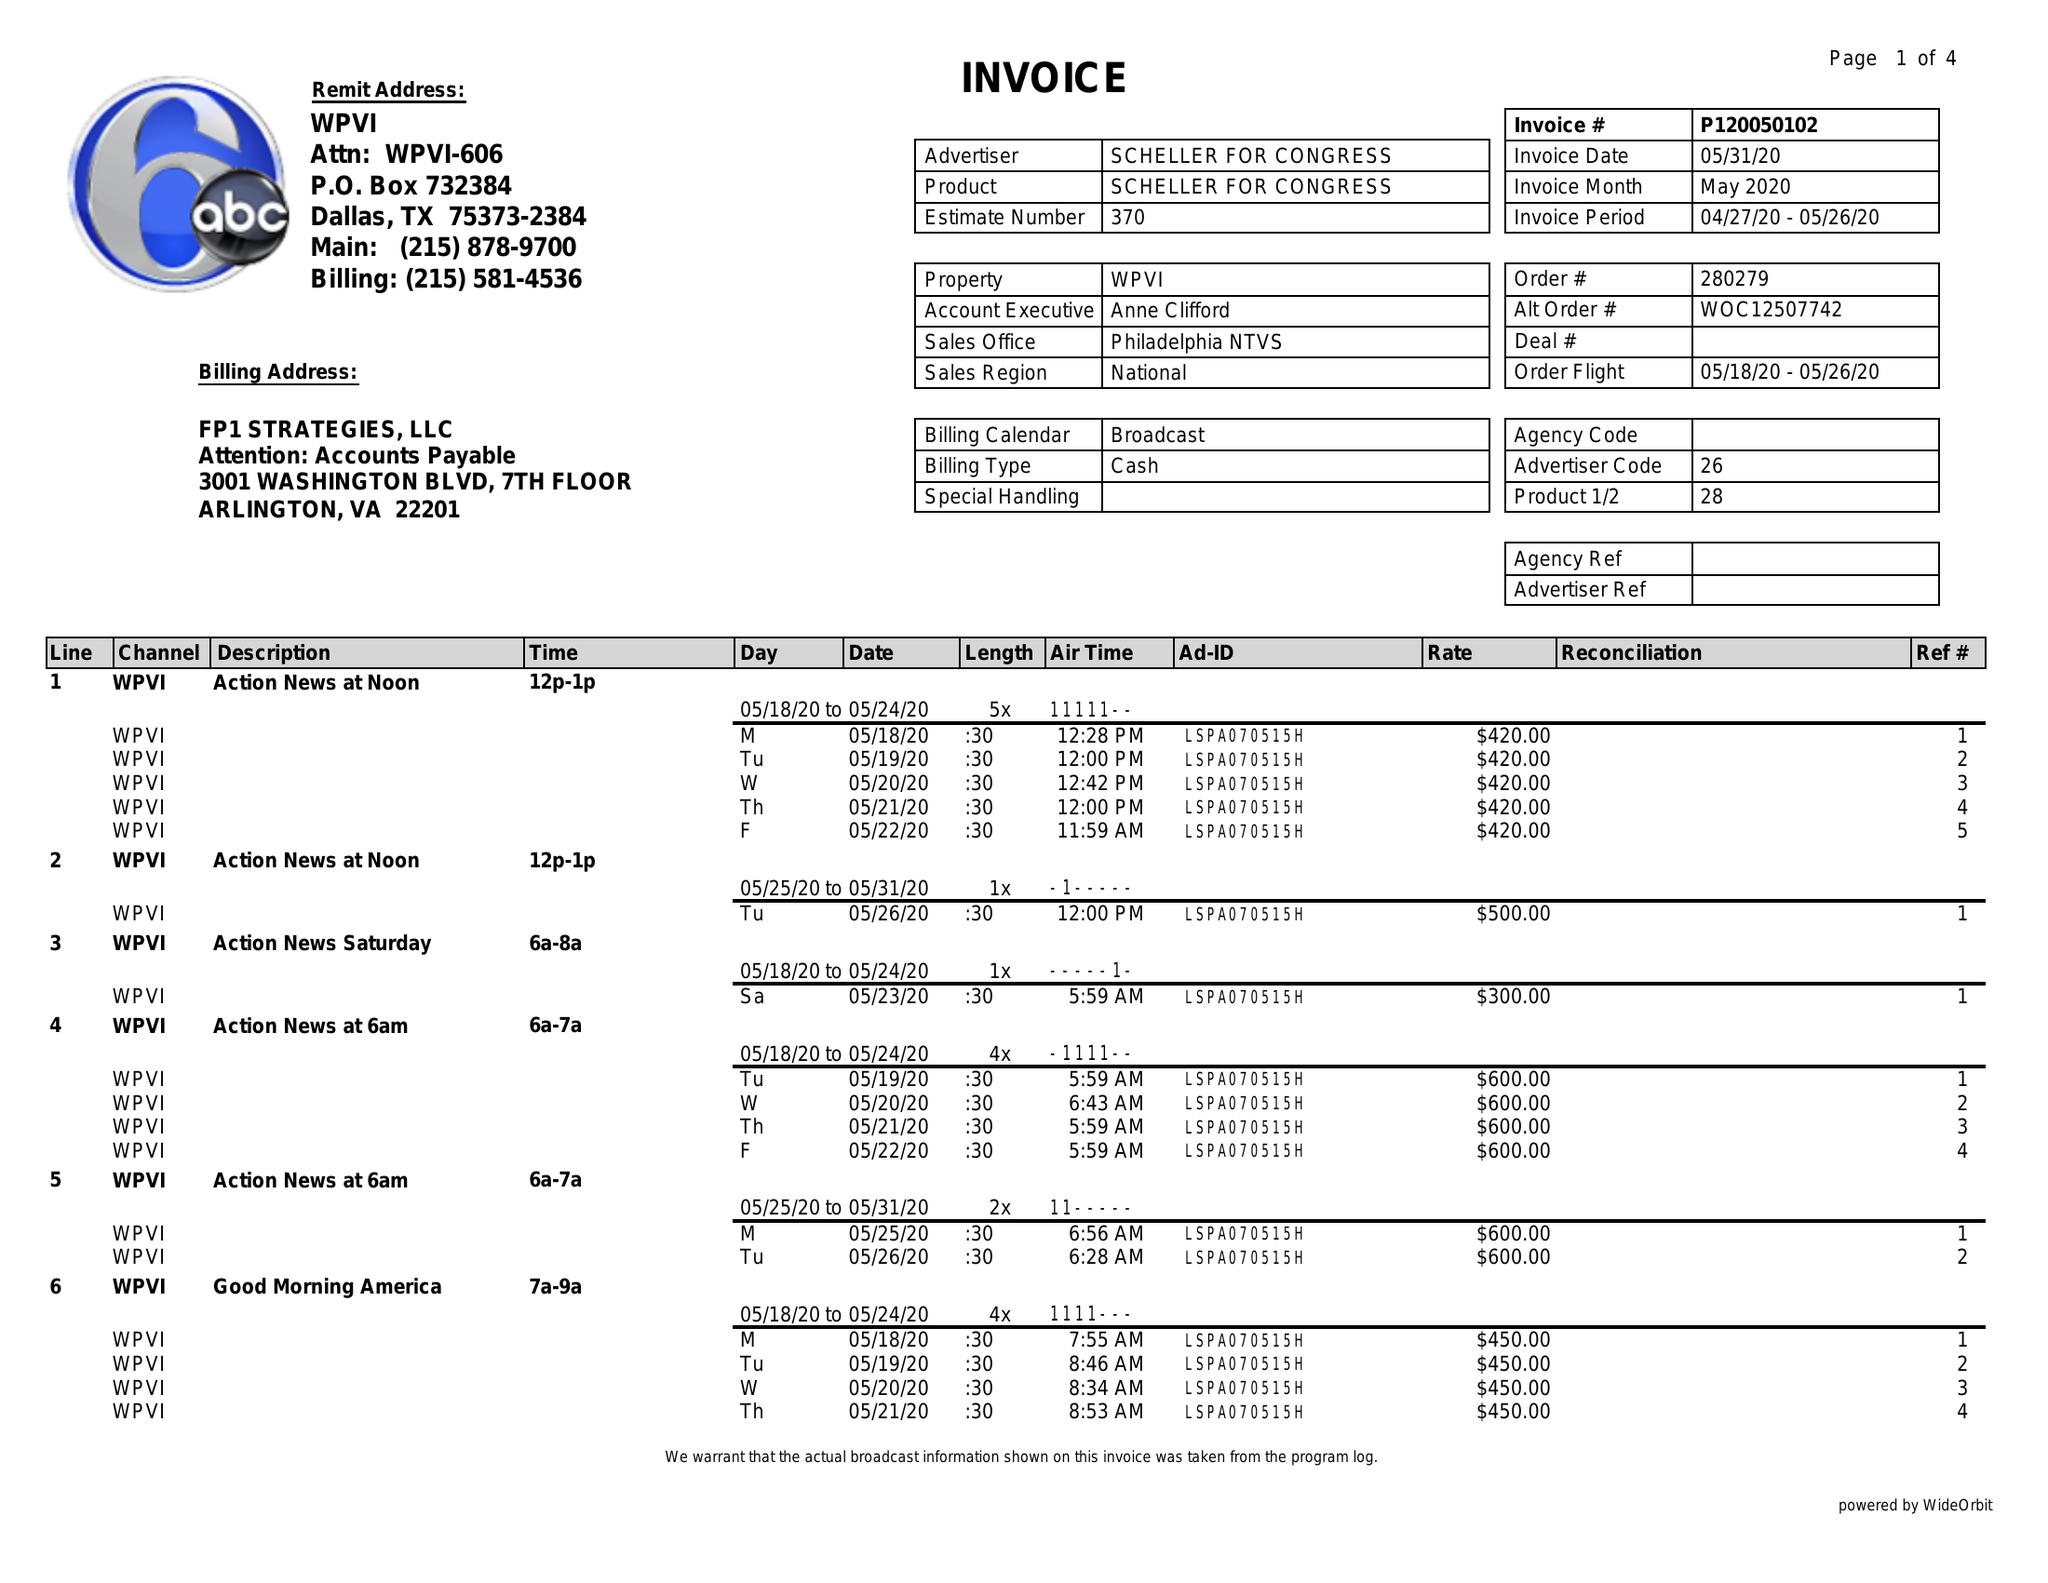What is the value for the gross_amount?
Answer the question using a single word or phrase. 34220.00 